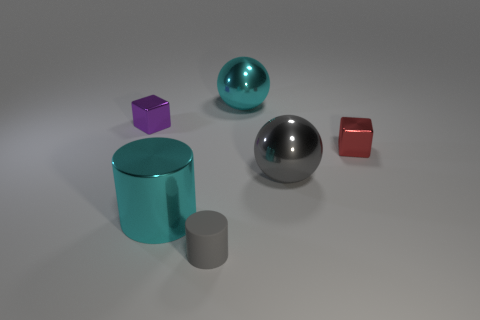Does the metallic sphere that is in front of the red object have the same size as the large cyan sphere?
Your answer should be compact. Yes. What is the material of the small red object that is the same shape as the tiny purple thing?
Your answer should be very brief. Metal. Do the rubber object and the big gray metal thing have the same shape?
Your answer should be compact. No. There is a small metallic cube that is on the right side of the large cyan sphere; what number of big cyan objects are behind it?
Your answer should be very brief. 1. There is a gray object that is the same material as the red thing; what is its shape?
Make the answer very short. Sphere. What number of blue objects are large shiny balls or shiny cubes?
Provide a succinct answer. 0. There is a sphere in front of the cyan shiny thing that is behind the purple object; is there a gray ball that is on the left side of it?
Offer a terse response. No. Is the number of tiny red metal blocks less than the number of large purple metal blocks?
Provide a succinct answer. No. There is a cyan metallic thing in front of the tiny red metallic object; is its shape the same as the purple thing?
Give a very brief answer. No. Is there a small gray cylinder?
Keep it short and to the point. Yes. 